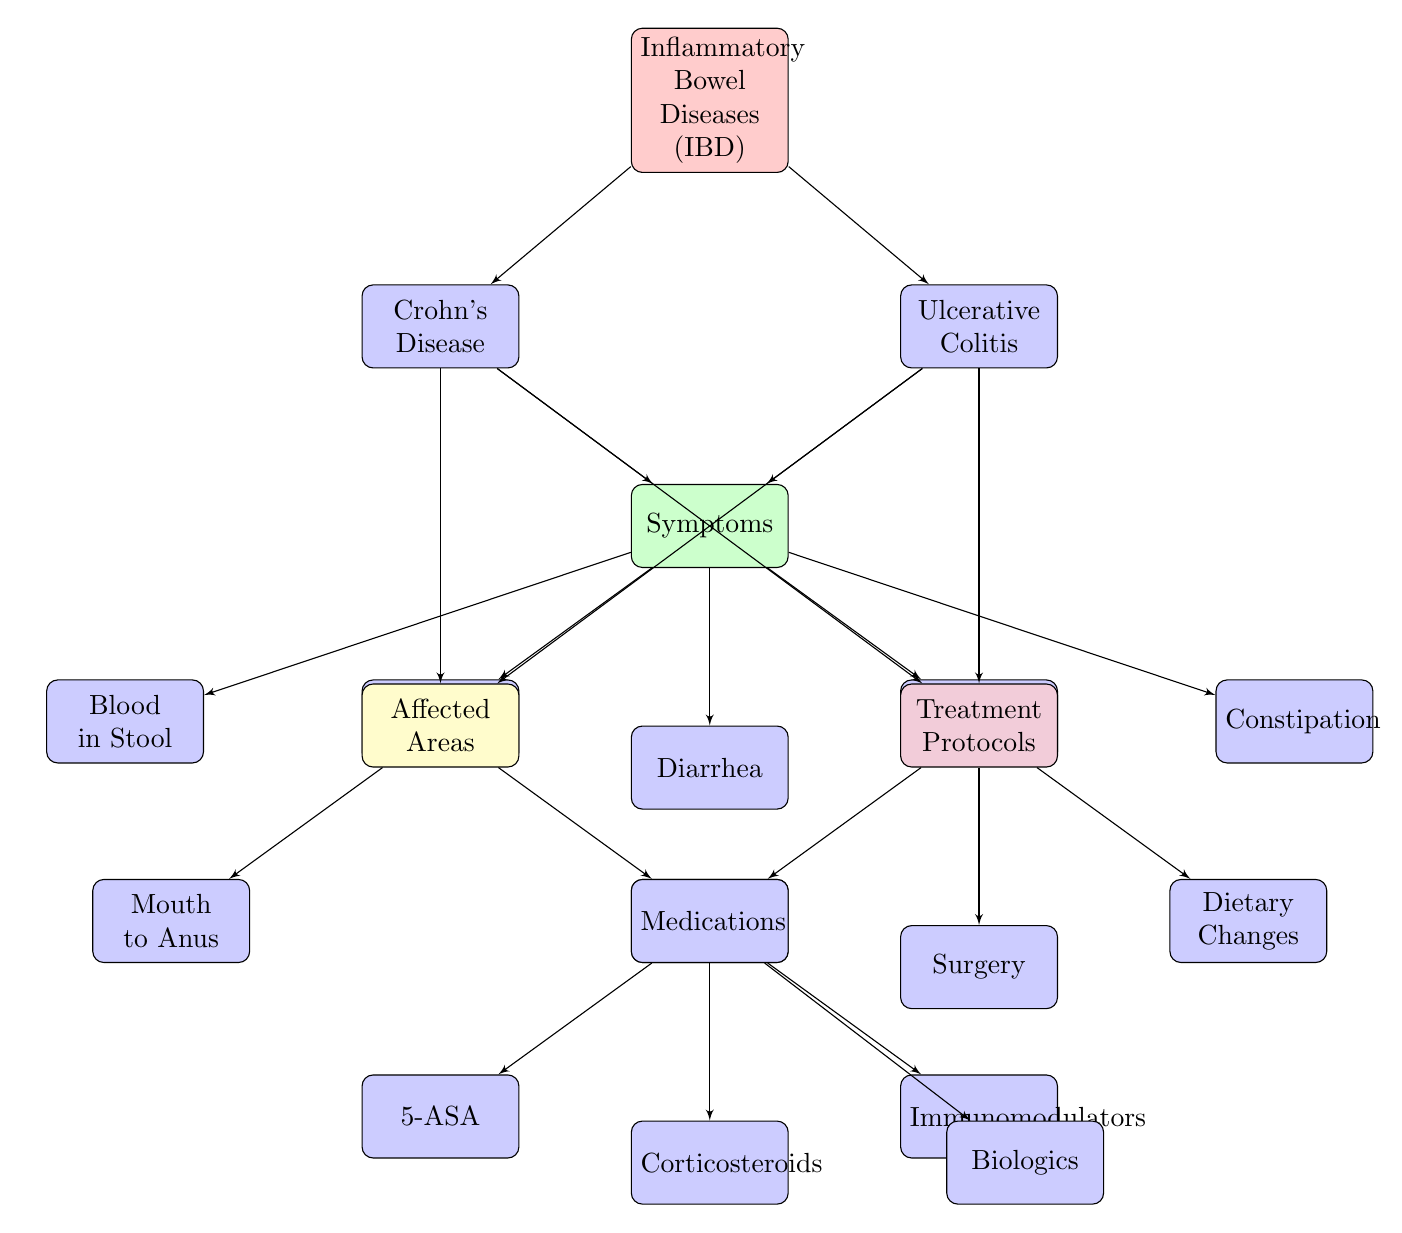What are the two main types of inflammatory bowel diseases shown? The diagram identifies the main types of inflammatory bowel diseases (IBD) as Crohn's Disease and Ulcerative Colitis, both branching from the main IBD node.
Answer: Crohn's Disease, Ulcerative Colitis Which symptom is listed under both Crohn's Disease and Ulcerative Colitis? The symptom "Diarrhea" is connected to both Crohn's Disease and Ulcerative Colitis in the diagram, indicating it is common for both types of IBD.
Answer: Diarrhea How many treatment protocols are mentioned in the diagram? The treatment protocols section of the diagram includes three main protocols: Medications, Surgery, and Dietary Changes, thus there are a total of three treatment protocols.
Answer: 3 What is the affected area for Crohn's Disease? According to the diagram, Crohn's Disease affects the "Mouth to Anus" region, indicated as branching off from the affected areas node linked to Crohn's Disease.
Answer: Mouth to Anus Which medication type is linked to corticosteroids? The diagram specifies "Corticosteroids" under the Medications node, showing it is a specific type of medication used in treatment protocols for IBD.
Answer: Corticosteroids What are the symptoms of IBD connected to under the Symptoms node? The Symptoms node in the diagram is connected to Abdominal Pain, Diarrhea, Weight Loss, Blood in Stool, and Constipation, indicating these are symptoms of IBD.
Answer: Abdominal Pain, Diarrhea, Weight Loss, Blood in Stool, Constipation How many total affected areas are indicated in the diagram? The affected areas node highlights two main locations: Mouth to Anus and Colon and Rectum, leading to a total of two affected areas in the diagram.
Answer: 2 Which specific treatment protocol is associated with dietary adjustments? The diagram includes "Dietary Changes" as one of the treatment protocols under the Treatment node, showing that it is a recommended approach for managing IBD.
Answer: Dietary Changes What type of medication is indicated as a biologic? The diagram provides "Biologics" as a specific medication type listed under the Medications node associated with treatment of IBD.
Answer: Biologics 